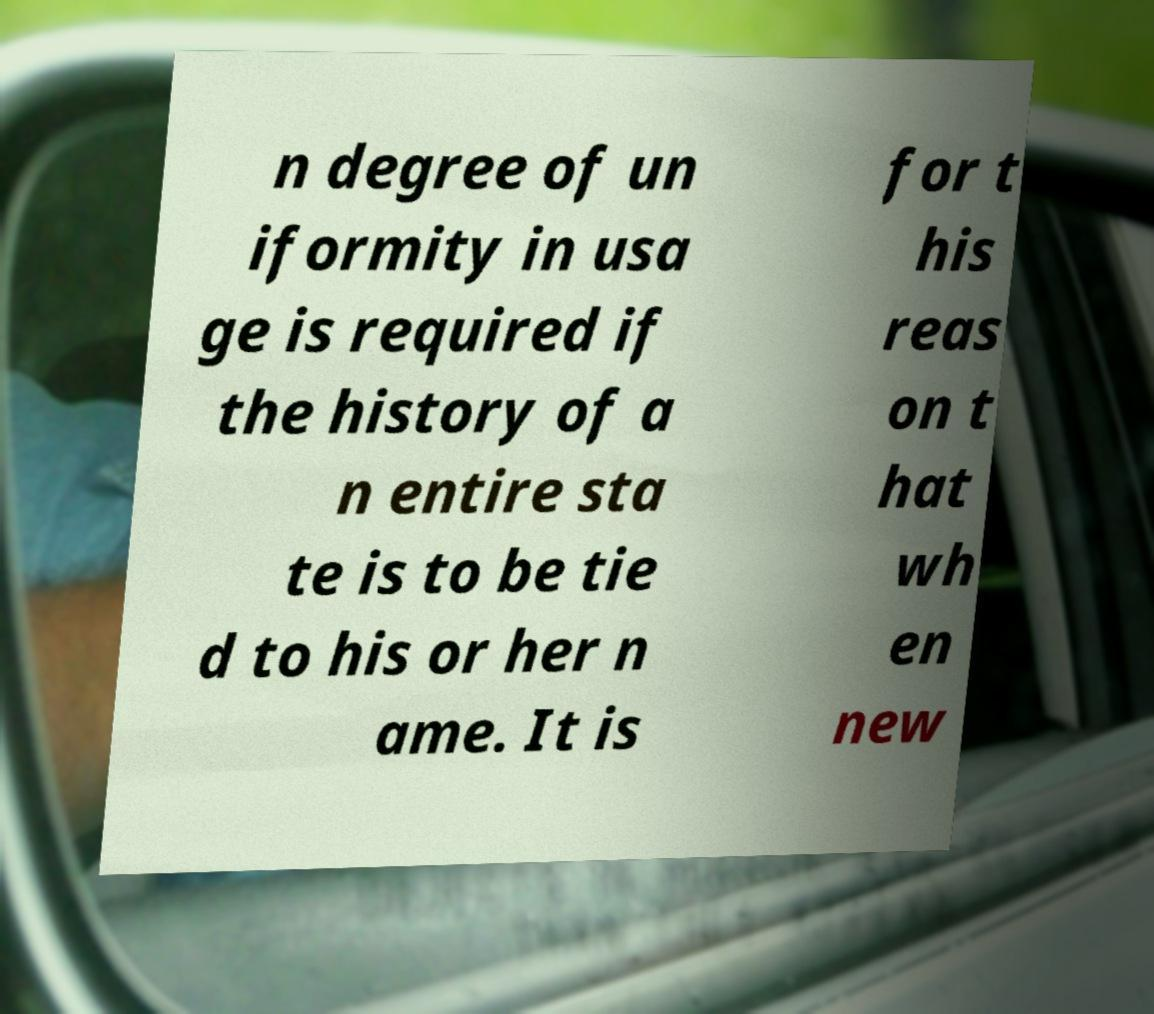What messages or text are displayed in this image? I need them in a readable, typed format. n degree of un iformity in usa ge is required if the history of a n entire sta te is to be tie d to his or her n ame. It is for t his reas on t hat wh en new 